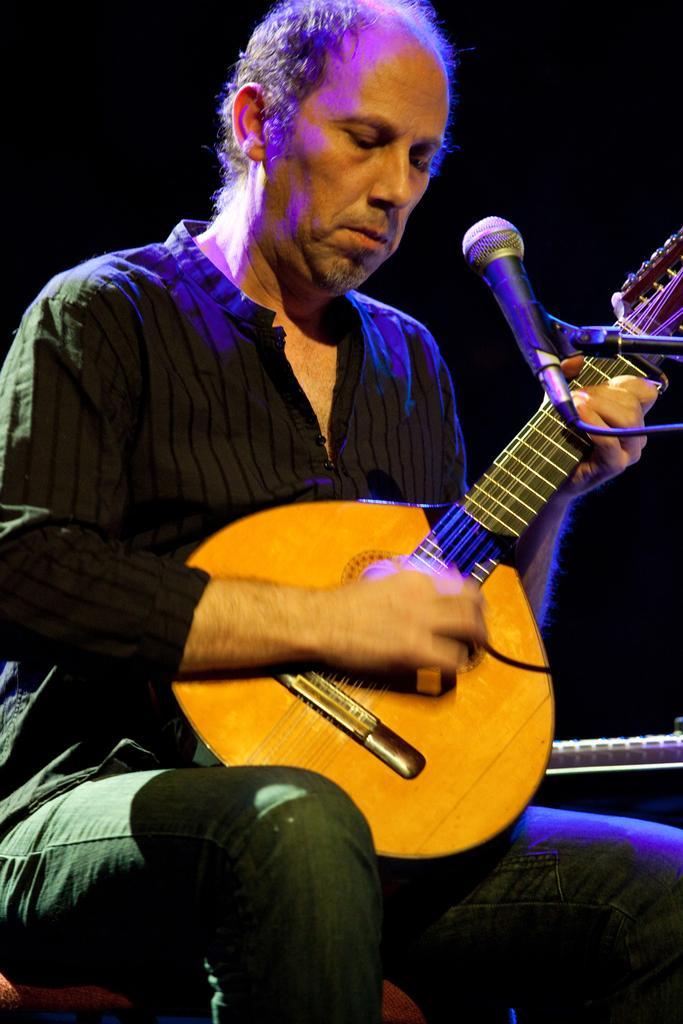In one or two sentences, can you explain what this image depicts? This picture seems to be of inside. In the foreground we can see a man wearing shirt, playing guitar and sitting. There is a microphone attached to the stand and the background is very dark. 